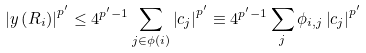<formula> <loc_0><loc_0><loc_500><loc_500>\left | y \left ( R _ { i } \right ) \right | ^ { p ^ { \prime } } \leq 4 ^ { p ^ { \prime } - 1 } \sum _ { j \in \phi \left ( i \right ) } \left | c _ { j } \right | ^ { p ^ { \prime } } \equiv 4 ^ { p ^ { \prime } - 1 } \sum _ { j } \phi _ { i , j } \left | c _ { j } \right | ^ { p ^ { \prime } }</formula> 